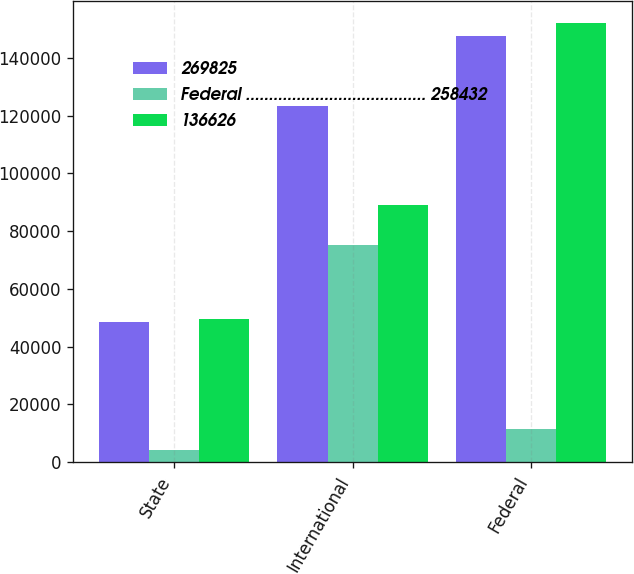Convert chart. <chart><loc_0><loc_0><loc_500><loc_500><stacked_bar_chart><ecel><fcel>State<fcel>International<fcel>Federal<nl><fcel>269825<fcel>48460<fcel>123297<fcel>147604<nl><fcel>Federal ....................................... 258432<fcel>4133<fcel>75310<fcel>11410<nl><fcel>136626<fcel>49656<fcel>89067<fcel>152041<nl></chart> 